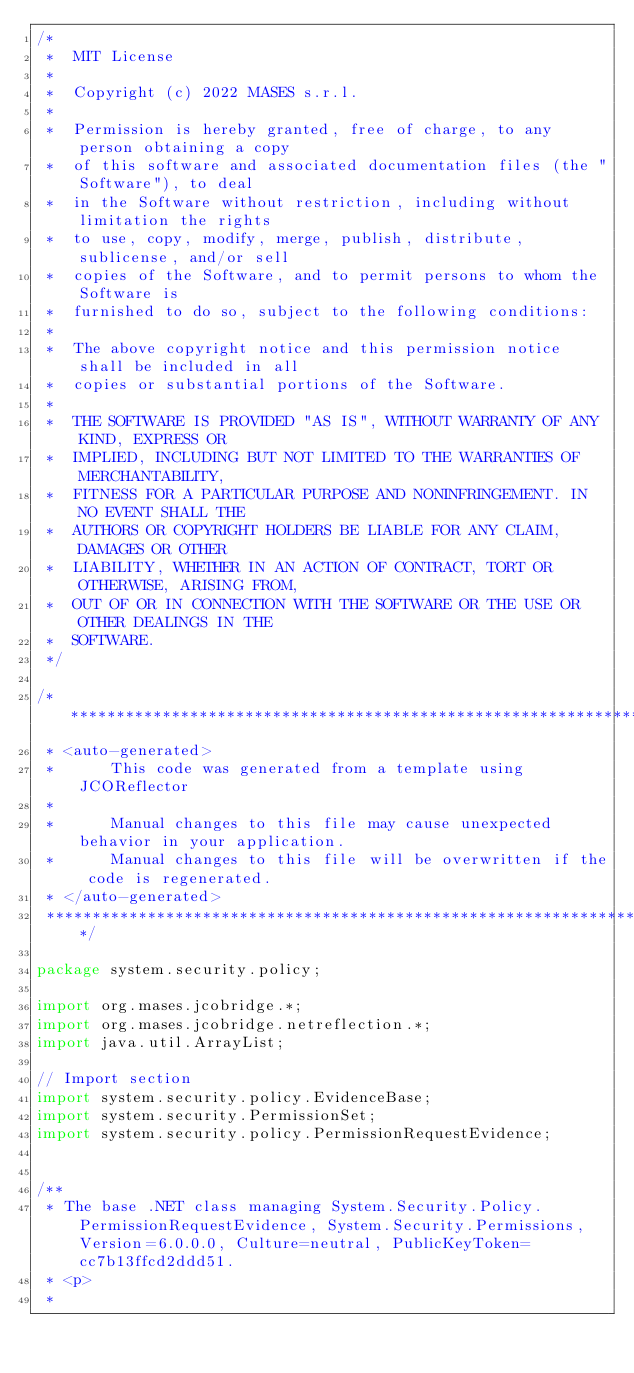Convert code to text. <code><loc_0><loc_0><loc_500><loc_500><_Java_>/*
 *  MIT License
 *
 *  Copyright (c) 2022 MASES s.r.l.
 *
 *  Permission is hereby granted, free of charge, to any person obtaining a copy
 *  of this software and associated documentation files (the "Software"), to deal
 *  in the Software without restriction, including without limitation the rights
 *  to use, copy, modify, merge, publish, distribute, sublicense, and/or sell
 *  copies of the Software, and to permit persons to whom the Software is
 *  furnished to do so, subject to the following conditions:
 *
 *  The above copyright notice and this permission notice shall be included in all
 *  copies or substantial portions of the Software.
 *
 *  THE SOFTWARE IS PROVIDED "AS IS", WITHOUT WARRANTY OF ANY KIND, EXPRESS OR
 *  IMPLIED, INCLUDING BUT NOT LIMITED TO THE WARRANTIES OF MERCHANTABILITY,
 *  FITNESS FOR A PARTICULAR PURPOSE AND NONINFRINGEMENT. IN NO EVENT SHALL THE
 *  AUTHORS OR COPYRIGHT HOLDERS BE LIABLE FOR ANY CLAIM, DAMAGES OR OTHER
 *  LIABILITY, WHETHER IN AN ACTION OF CONTRACT, TORT OR OTHERWISE, ARISING FROM,
 *  OUT OF OR IN CONNECTION WITH THE SOFTWARE OR THE USE OR OTHER DEALINGS IN THE
 *  SOFTWARE.
 */

/**************************************************************************************
 * <auto-generated>
 *      This code was generated from a template using JCOReflector
 * 
 *      Manual changes to this file may cause unexpected behavior in your application.
 *      Manual changes to this file will be overwritten if the code is regenerated.
 * </auto-generated>
 *************************************************************************************/

package system.security.policy;

import org.mases.jcobridge.*;
import org.mases.jcobridge.netreflection.*;
import java.util.ArrayList;

// Import section
import system.security.policy.EvidenceBase;
import system.security.PermissionSet;
import system.security.policy.PermissionRequestEvidence;


/**
 * The base .NET class managing System.Security.Policy.PermissionRequestEvidence, System.Security.Permissions, Version=6.0.0.0, Culture=neutral, PublicKeyToken=cc7b13ffcd2ddd51.
 * <p>
 * </code> 